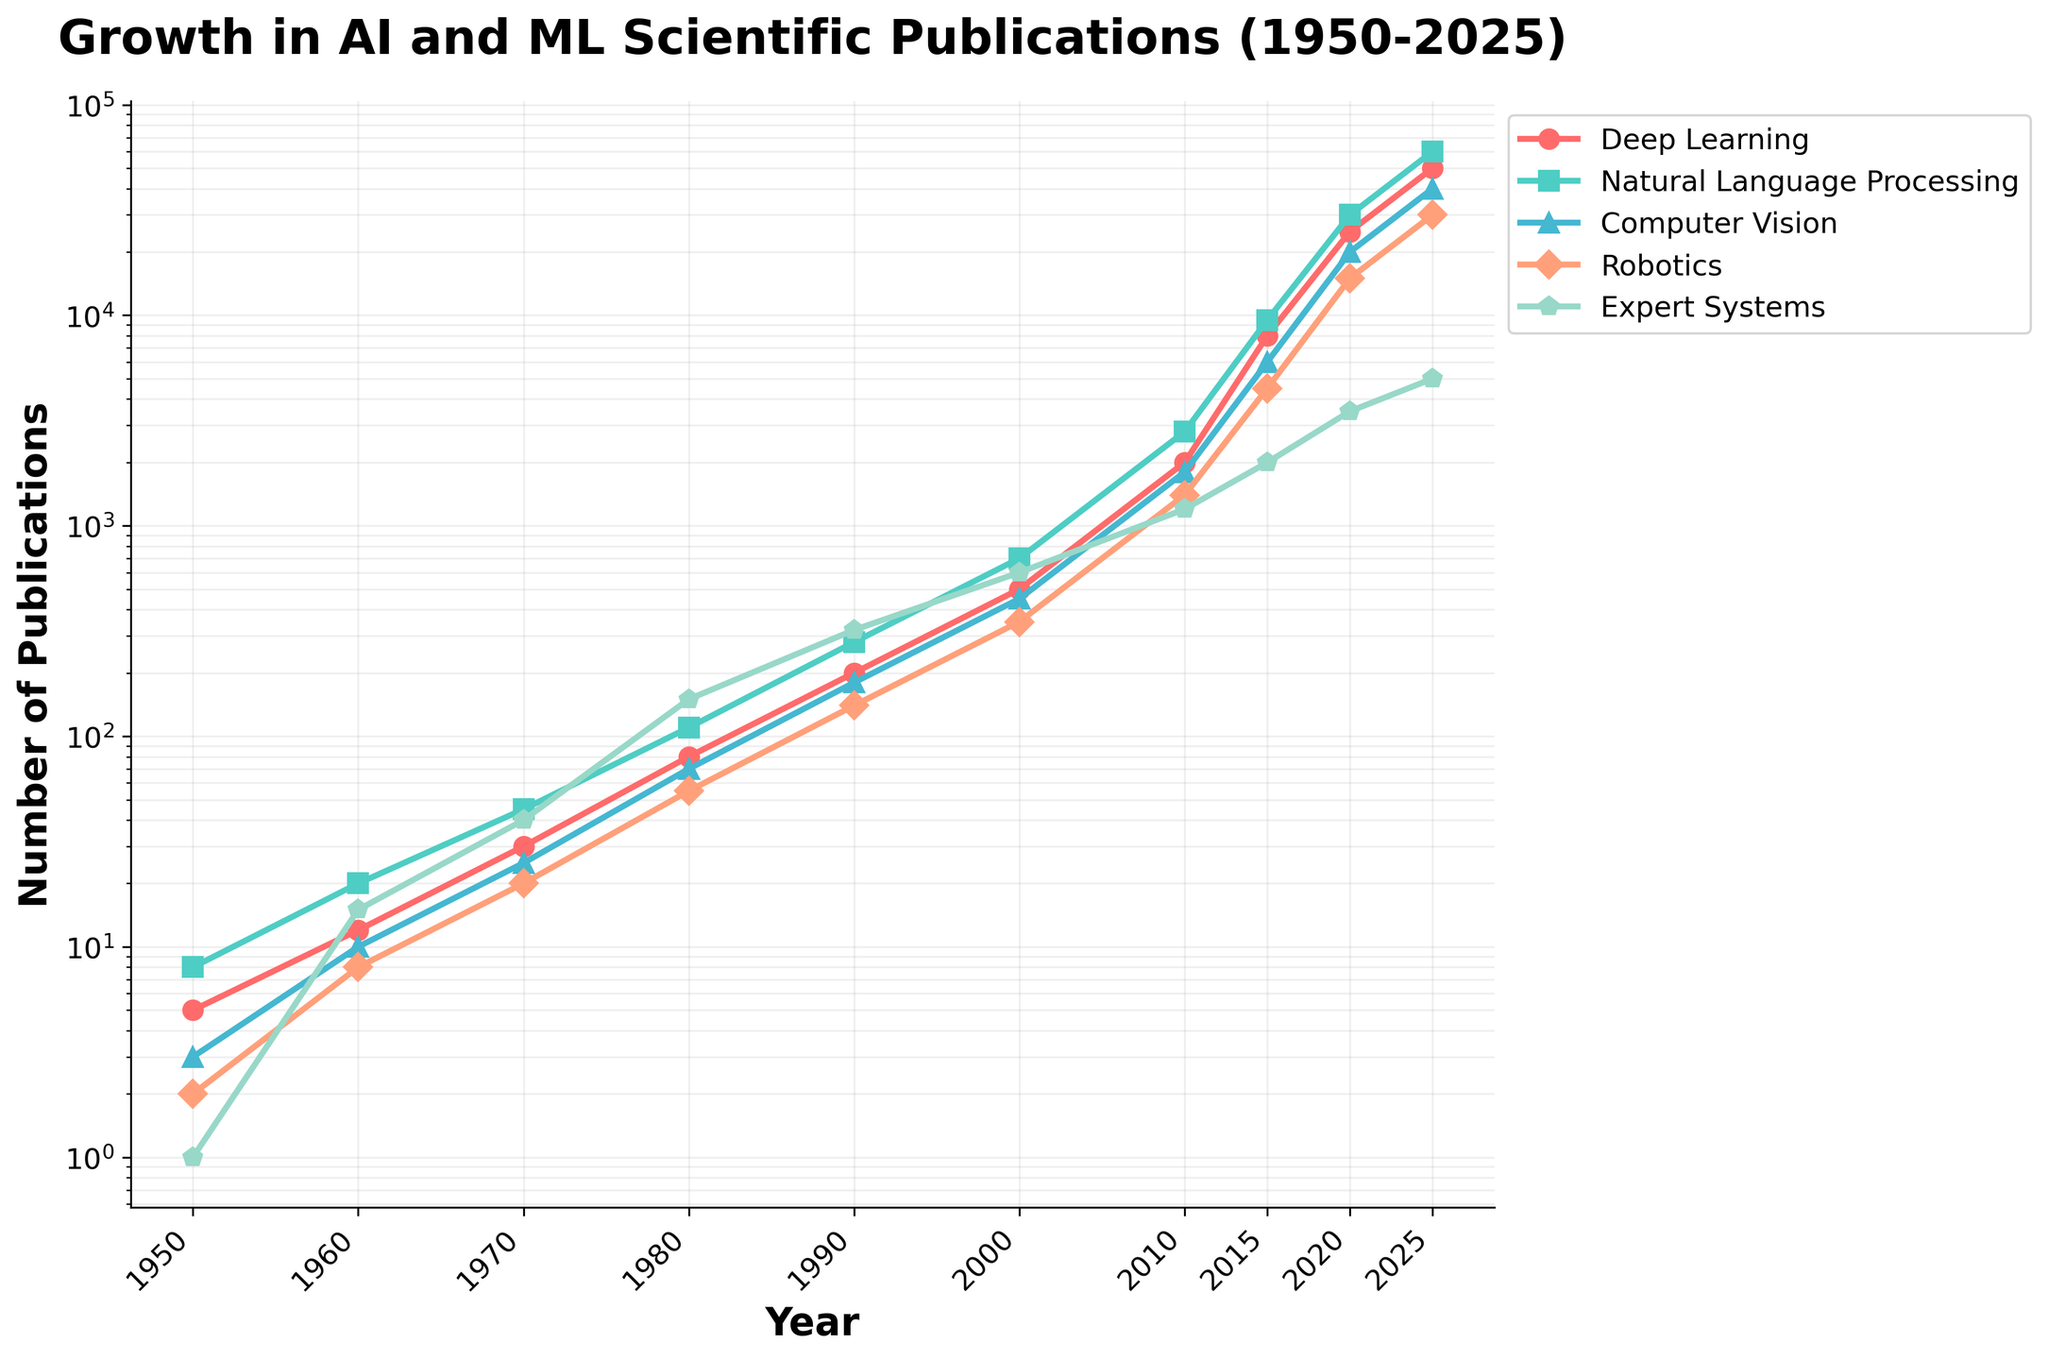Which year saw the highest number of publications in the Natural Language Processing subfield? Look at the line representing Natural Language Processing and find the peak point along the x-axis. The highest point is at 2025.
Answer: 2025 How many more publications were there in Deep Learning in 2025 compared to 2010? Check the values for Deep Learning in 2010 and 2025. In 2010, it is 2000 and in 2025, it is 50000. Calculate the difference: 50000 - 2000 = 48000.
Answer: 48000 Which subfield had the least number of publications in 1950? Look at the starting point of each subfield's line for the year 1950. Expert Systems has the lowest value at 1 publication.
Answer: Expert Systems What is the approximate ratio of the number of publications in Robotics to Computer Vision in 2020? Find the values for Robotics (15000) and Computer Vision (20000) in 2020. Calculate the ratio: 15000 / 20000 = 0.75.
Answer: 0.75 In which years did the number of publications in Natural Language Processing exceed those in Expert Systems? Compare the values year by year for Natural Language Processing and Expert Systems. Natural Language Processing exceeds Expert Systems in 2010 (2800 vs. 1200), 2015 (9500 vs. 2000), 2020 (30000 vs. 3500), and 2025 (60000 vs. 5000).
Answer: 2010, 2015, 2020, 2025 What is the growth factor of Computer Vision publications from 1960 to 1990? Find the publication numbers for Computer Vision in 1960 (10) and 1990 (180). Calculate the growth factor: 180 / 10 = 18.
Answer: 18 Among all subfields, which had the highest publication growth rate between 2015 and 2020? Calculate the growth rate for each subfield: 
Deep Learning: (25000-8000)/8000 = 2.125
Natural Language Processing: (30000-9500)/9500 = 2.158
Computer Vision: (20000-6000)/6000 = 2.333
Robotics: (15000-4500)/4500 = 2.333
Expert Systems: (3500-2000)/2000 = 0.75
Computer Vision and Robotics both have the highest growth rate of 2.333.
Answer: Computer Vision, Robotics What’s the total number of publications across all subfields in the year 2000? Sum the publication numbers for all subfields in 2000: 500 (Deep Learning) + 700 (Natural Language Processing) + 450 (Computer Vision) + 350 (Robotics) + 600 (Expert Systems) = 2600.
Answer: 2600 How does the number of publications in Robotics in 1980 compare to that in Expert Systems in 1970? Find the values for Robotics in 1980 (55) and Expert Systems in 1970 (40). Compare the two: 55 > 40.
Answer: 55 > 40 What was the average yearly growth in the number of publications for Deep Learning between 2015 and 2025? Calculate the difference in publications for Deep Learning between 2025 (50000) and 2015 (8000). Difference is 50000 - 8000 = 42000. There are 10 years between 2015 and 2025, so the average yearly growth is 42000 / 10 = 4200.
Answer: 4200 